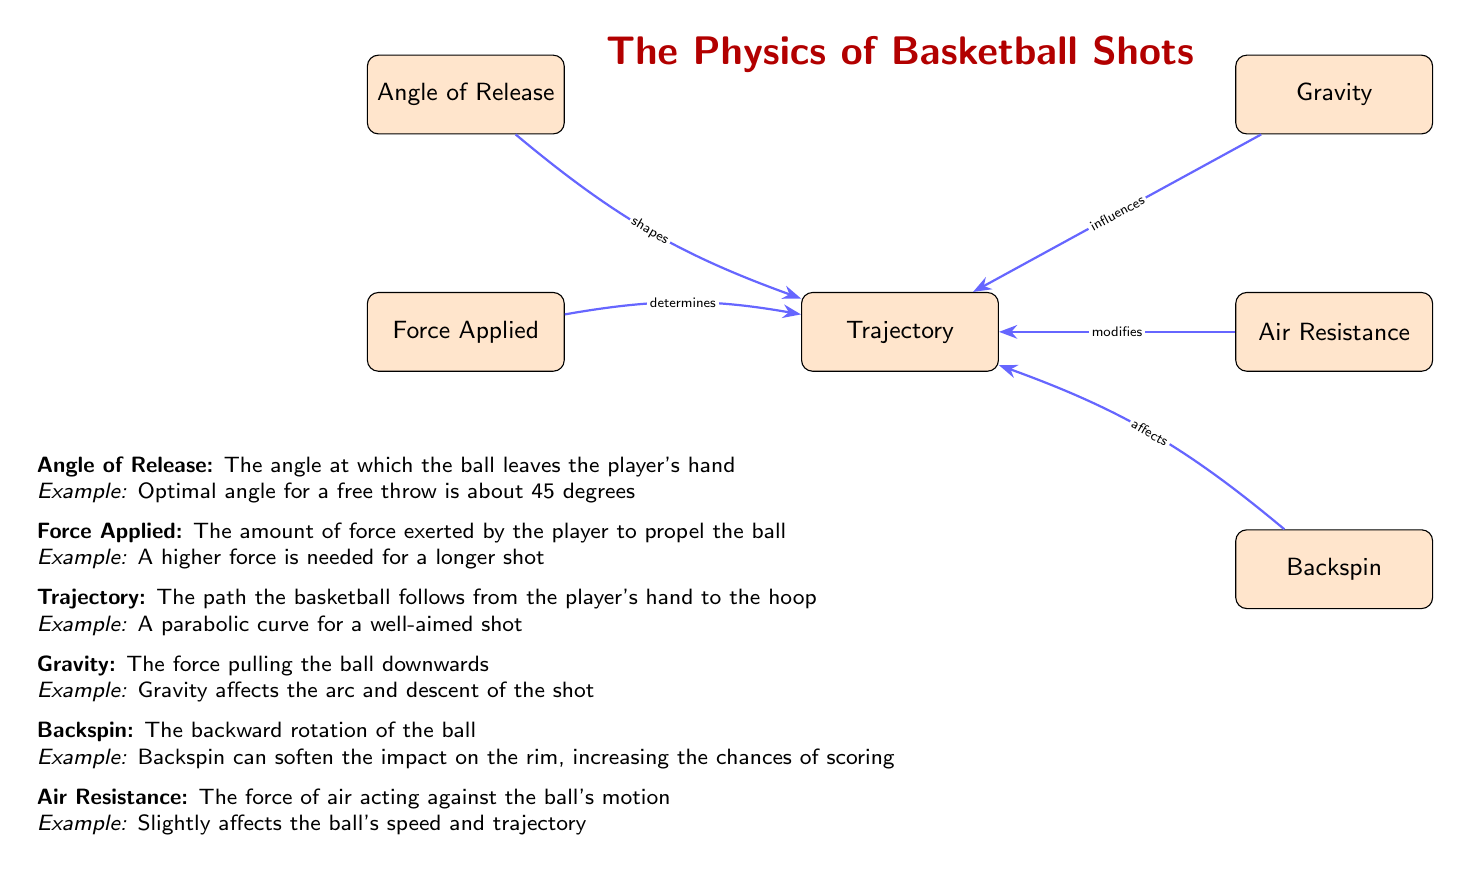What are the main factors influencing the trajectory of a basketball shot? The diagram lists five main factors that influence the trajectory: Angle of Release, Force Applied, Gravity, Backspin, and Air Resistance. This information is found within the nodes connected to Trajectory, indicating their individual and collective roles.
Answer: Angle of Release, Force Applied, Gravity, Backspin, Air Resistance How does backspin affect the trajectory? The arrow connecting Backspin to Trajectory indicates that backspin specifically affects the trajectory by softening the impact on the rim, thereby increasing the chances of scoring. This reasoning can be inferred by understanding the relationship depicted in the diagram.
Answer: Affects What is the relationship between force applied and trajectory? The diagram shows that the Force Applied connects to the Trajectory with an arrow labeled "determines". This indicates that the amount of force a player exerts directly determines how the basketball's trajectory will behave when shot.
Answer: Determines What angle is optimal for a free throw according to the diagram? The diagram states in the description of Angle of Release that an optimal angle for a free throw is about 45 degrees. This is given as an example, making it clear and straightforward to identify.
Answer: 45 degrees How many factors are shown to influence the trajectory? By counting the nodes connected to Trajectory, we see there are five distinct factors or influences: Angle of Release, Force Applied, Gravity, Backspin, and Air Resistance. This is a direct count based on the diagram.
Answer: Five What role does air resistance play according to the diagram? The diagram indicates through the connection labeled "modifies" that Air Resistance modifies the trajectory of the basketball. Analyzing the arrow pointing at Trajectory reinforces that it does not determine or affect it in a standard way but rather modifies it.
Answer: Modifies Which factor is described as having an effect on the arc of the shot? The diagram's description of Gravity explains its influence on the arc and descent of the shot, indicating that it is responsible for shaping how the basketball moves through the air after the release. This factor connects directly to the trajectory as well.
Answer: Gravity How does the angle of release relate to the trajectory type? The diagram states that the Angle of Release "shapes" the trajectory, indicating that this angle is significant in defining the path or type of trajectory the basketball will follow when shot. The word "shapes" shows the direct effect of the angle on the trajectory.
Answer: Shapes What example is given for force applied? The diagram includes an example under the Force Applied description that states a higher force is needed for a longer shot. This context clarifies how the force is not only a physical push but its magnitude changes based on the type of shot taken.
Answer: A higher force is needed for a longer shot 